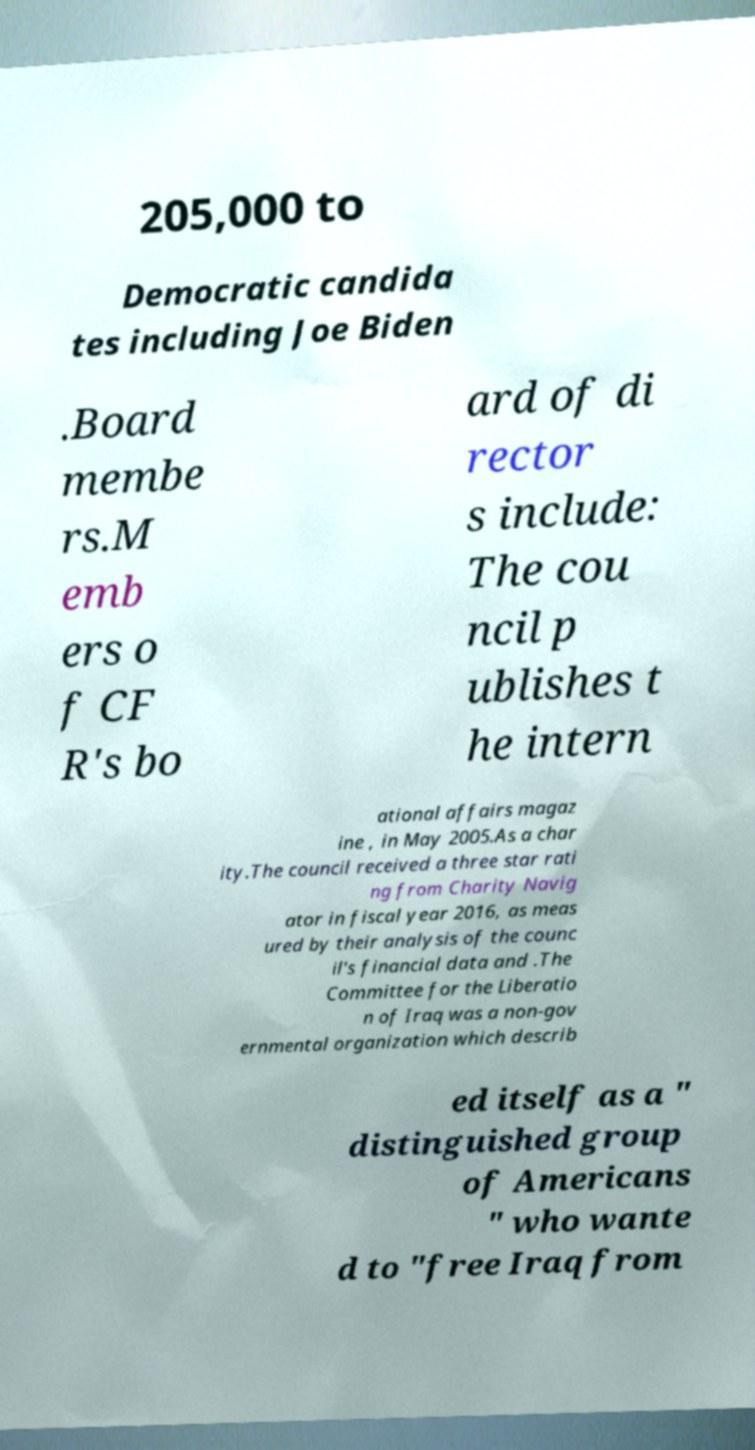What messages or text are displayed in this image? I need them in a readable, typed format. 205,000 to Democratic candida tes including Joe Biden .Board membe rs.M emb ers o f CF R's bo ard of di rector s include: The cou ncil p ublishes t he intern ational affairs magaz ine , in May 2005.As a char ity.The council received a three star rati ng from Charity Navig ator in fiscal year 2016, as meas ured by their analysis of the counc il's financial data and .The Committee for the Liberatio n of Iraq was a non-gov ernmental organization which describ ed itself as a " distinguished group of Americans " who wante d to "free Iraq from 